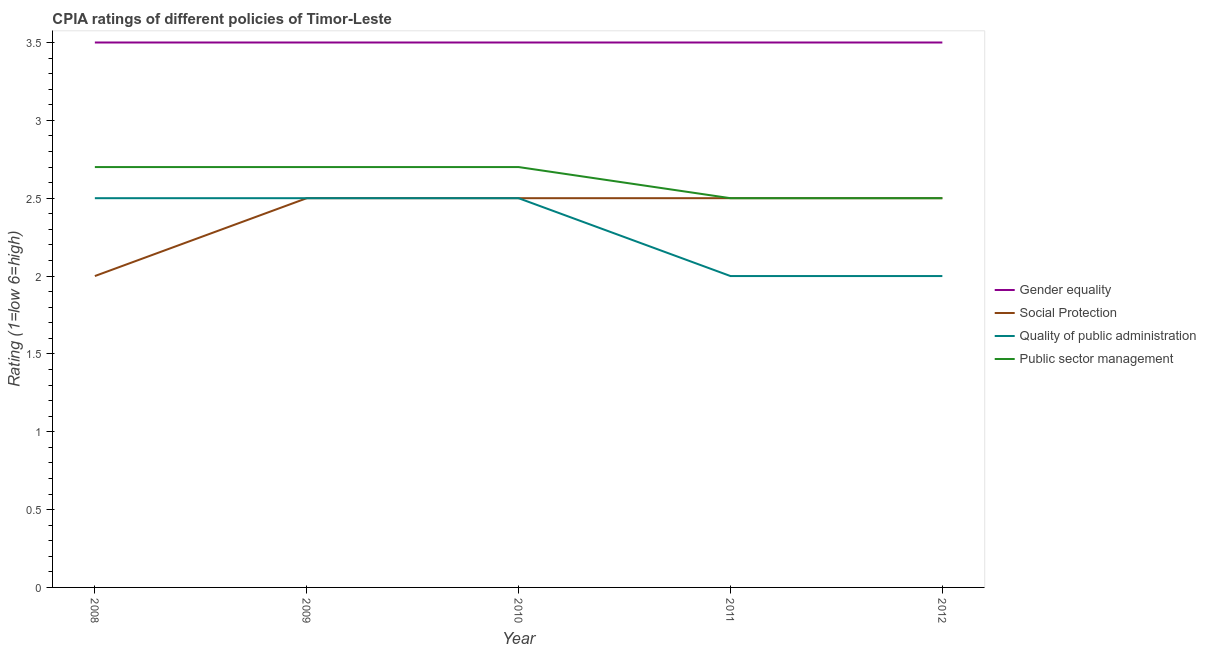How many different coloured lines are there?
Offer a very short reply. 4. Does the line corresponding to cpia rating of social protection intersect with the line corresponding to cpia rating of quality of public administration?
Keep it short and to the point. Yes. Across all years, what is the maximum cpia rating of gender equality?
Give a very brief answer. 3.5. In which year was the cpia rating of social protection maximum?
Provide a succinct answer. 2009. What is the difference between the cpia rating of public sector management in 2008 and the cpia rating of quality of public administration in 2010?
Your response must be concise. 0.2. What is the average cpia rating of quality of public administration per year?
Provide a succinct answer. 2.3. In the year 2012, what is the difference between the cpia rating of quality of public administration and cpia rating of gender equality?
Your response must be concise. -1.5. In how many years, is the cpia rating of quality of public administration greater than 2.8?
Your answer should be compact. 0. What is the ratio of the cpia rating of gender equality in 2009 to that in 2010?
Make the answer very short. 1. Is the cpia rating of social protection in 2008 less than that in 2011?
Make the answer very short. Yes. Is the difference between the cpia rating of social protection in 2009 and 2012 greater than the difference between the cpia rating of quality of public administration in 2009 and 2012?
Give a very brief answer. No. Is the sum of the cpia rating of social protection in 2008 and 2011 greater than the maximum cpia rating of public sector management across all years?
Your answer should be very brief. Yes. Is it the case that in every year, the sum of the cpia rating of quality of public administration and cpia rating of public sector management is greater than the sum of cpia rating of gender equality and cpia rating of social protection?
Ensure brevity in your answer.  No. Is it the case that in every year, the sum of the cpia rating of gender equality and cpia rating of social protection is greater than the cpia rating of quality of public administration?
Provide a short and direct response. Yes. Does the cpia rating of social protection monotonically increase over the years?
Give a very brief answer. No. Is the cpia rating of public sector management strictly less than the cpia rating of gender equality over the years?
Keep it short and to the point. Yes. Are the values on the major ticks of Y-axis written in scientific E-notation?
Provide a short and direct response. No. Does the graph contain any zero values?
Your response must be concise. No. Does the graph contain grids?
Give a very brief answer. No. How many legend labels are there?
Provide a succinct answer. 4. How are the legend labels stacked?
Your response must be concise. Vertical. What is the title of the graph?
Ensure brevity in your answer.  CPIA ratings of different policies of Timor-Leste. What is the Rating (1=low 6=high) of Social Protection in 2008?
Offer a very short reply. 2. What is the Rating (1=low 6=high) in Quality of public administration in 2008?
Ensure brevity in your answer.  2.5. What is the Rating (1=low 6=high) in Public sector management in 2008?
Make the answer very short. 2.7. What is the Rating (1=low 6=high) in Social Protection in 2009?
Offer a very short reply. 2.5. What is the Rating (1=low 6=high) of Public sector management in 2009?
Keep it short and to the point. 2.7. What is the Rating (1=low 6=high) of Gender equality in 2010?
Make the answer very short. 3.5. What is the Rating (1=low 6=high) of Quality of public administration in 2010?
Ensure brevity in your answer.  2.5. What is the Rating (1=low 6=high) in Gender equality in 2011?
Ensure brevity in your answer.  3.5. What is the Rating (1=low 6=high) in Gender equality in 2012?
Make the answer very short. 3.5. What is the Rating (1=low 6=high) in Quality of public administration in 2012?
Your answer should be compact. 2. What is the Rating (1=low 6=high) in Public sector management in 2012?
Make the answer very short. 2.5. Across all years, what is the maximum Rating (1=low 6=high) of Social Protection?
Your answer should be very brief. 2.5. Across all years, what is the maximum Rating (1=low 6=high) of Public sector management?
Provide a succinct answer. 2.7. Across all years, what is the minimum Rating (1=low 6=high) in Social Protection?
Your answer should be compact. 2. What is the total Rating (1=low 6=high) in Gender equality in the graph?
Offer a very short reply. 17.5. What is the total Rating (1=low 6=high) in Quality of public administration in the graph?
Make the answer very short. 11.5. What is the difference between the Rating (1=low 6=high) in Gender equality in 2008 and that in 2009?
Ensure brevity in your answer.  0. What is the difference between the Rating (1=low 6=high) of Social Protection in 2008 and that in 2009?
Provide a succinct answer. -0.5. What is the difference between the Rating (1=low 6=high) in Public sector management in 2008 and that in 2010?
Offer a very short reply. 0. What is the difference between the Rating (1=low 6=high) in Gender equality in 2008 and that in 2011?
Provide a short and direct response. 0. What is the difference between the Rating (1=low 6=high) in Social Protection in 2008 and that in 2011?
Your response must be concise. -0.5. What is the difference between the Rating (1=low 6=high) in Public sector management in 2008 and that in 2011?
Ensure brevity in your answer.  0.2. What is the difference between the Rating (1=low 6=high) of Quality of public administration in 2008 and that in 2012?
Offer a terse response. 0.5. What is the difference between the Rating (1=low 6=high) in Gender equality in 2009 and that in 2010?
Keep it short and to the point. 0. What is the difference between the Rating (1=low 6=high) of Social Protection in 2009 and that in 2011?
Provide a short and direct response. 0. What is the difference between the Rating (1=low 6=high) in Quality of public administration in 2009 and that in 2011?
Provide a succinct answer. 0.5. What is the difference between the Rating (1=low 6=high) in Gender equality in 2009 and that in 2012?
Your answer should be compact. 0. What is the difference between the Rating (1=low 6=high) of Gender equality in 2010 and that in 2011?
Your answer should be compact. 0. What is the difference between the Rating (1=low 6=high) of Social Protection in 2010 and that in 2011?
Keep it short and to the point. 0. What is the difference between the Rating (1=low 6=high) of Gender equality in 2010 and that in 2012?
Make the answer very short. 0. What is the difference between the Rating (1=low 6=high) in Social Protection in 2010 and that in 2012?
Your answer should be compact. 0. What is the difference between the Rating (1=low 6=high) of Public sector management in 2010 and that in 2012?
Make the answer very short. 0.2. What is the difference between the Rating (1=low 6=high) of Social Protection in 2011 and that in 2012?
Make the answer very short. 0. What is the difference between the Rating (1=low 6=high) in Gender equality in 2008 and the Rating (1=low 6=high) in Quality of public administration in 2009?
Your response must be concise. 1. What is the difference between the Rating (1=low 6=high) in Gender equality in 2008 and the Rating (1=low 6=high) in Public sector management in 2009?
Your answer should be very brief. 0.8. What is the difference between the Rating (1=low 6=high) in Social Protection in 2008 and the Rating (1=low 6=high) in Quality of public administration in 2009?
Make the answer very short. -0.5. What is the difference between the Rating (1=low 6=high) of Gender equality in 2008 and the Rating (1=low 6=high) of Social Protection in 2010?
Ensure brevity in your answer.  1. What is the difference between the Rating (1=low 6=high) of Gender equality in 2008 and the Rating (1=low 6=high) of Public sector management in 2010?
Keep it short and to the point. 0.8. What is the difference between the Rating (1=low 6=high) in Social Protection in 2008 and the Rating (1=low 6=high) in Public sector management in 2010?
Provide a succinct answer. -0.7. What is the difference between the Rating (1=low 6=high) of Gender equality in 2008 and the Rating (1=low 6=high) of Social Protection in 2011?
Ensure brevity in your answer.  1. What is the difference between the Rating (1=low 6=high) of Gender equality in 2008 and the Rating (1=low 6=high) of Quality of public administration in 2011?
Your answer should be compact. 1.5. What is the difference between the Rating (1=low 6=high) of Gender equality in 2008 and the Rating (1=low 6=high) of Public sector management in 2011?
Your response must be concise. 1. What is the difference between the Rating (1=low 6=high) in Quality of public administration in 2008 and the Rating (1=low 6=high) in Public sector management in 2011?
Make the answer very short. 0. What is the difference between the Rating (1=low 6=high) of Gender equality in 2008 and the Rating (1=low 6=high) of Social Protection in 2012?
Give a very brief answer. 1. What is the difference between the Rating (1=low 6=high) of Gender equality in 2008 and the Rating (1=low 6=high) of Quality of public administration in 2012?
Provide a short and direct response. 1.5. What is the difference between the Rating (1=low 6=high) of Gender equality in 2008 and the Rating (1=low 6=high) of Public sector management in 2012?
Your response must be concise. 1. What is the difference between the Rating (1=low 6=high) in Social Protection in 2008 and the Rating (1=low 6=high) in Quality of public administration in 2012?
Keep it short and to the point. 0. What is the difference between the Rating (1=low 6=high) of Quality of public administration in 2008 and the Rating (1=low 6=high) of Public sector management in 2012?
Give a very brief answer. 0. What is the difference between the Rating (1=low 6=high) in Gender equality in 2009 and the Rating (1=low 6=high) in Quality of public administration in 2010?
Your answer should be compact. 1. What is the difference between the Rating (1=low 6=high) of Gender equality in 2009 and the Rating (1=low 6=high) of Public sector management in 2010?
Give a very brief answer. 0.8. What is the difference between the Rating (1=low 6=high) of Social Protection in 2009 and the Rating (1=low 6=high) of Quality of public administration in 2010?
Provide a short and direct response. 0. What is the difference between the Rating (1=low 6=high) in Social Protection in 2009 and the Rating (1=low 6=high) in Public sector management in 2010?
Offer a terse response. -0.2. What is the difference between the Rating (1=low 6=high) in Quality of public administration in 2009 and the Rating (1=low 6=high) in Public sector management in 2010?
Your answer should be very brief. -0.2. What is the difference between the Rating (1=low 6=high) in Social Protection in 2009 and the Rating (1=low 6=high) in Quality of public administration in 2011?
Provide a succinct answer. 0.5. What is the difference between the Rating (1=low 6=high) of Quality of public administration in 2009 and the Rating (1=low 6=high) of Public sector management in 2011?
Your answer should be compact. 0. What is the difference between the Rating (1=low 6=high) of Gender equality in 2009 and the Rating (1=low 6=high) of Social Protection in 2012?
Offer a terse response. 1. What is the difference between the Rating (1=low 6=high) in Gender equality in 2009 and the Rating (1=low 6=high) in Quality of public administration in 2012?
Your answer should be compact. 1.5. What is the difference between the Rating (1=low 6=high) in Gender equality in 2009 and the Rating (1=low 6=high) in Public sector management in 2012?
Provide a short and direct response. 1. What is the difference between the Rating (1=low 6=high) of Gender equality in 2010 and the Rating (1=low 6=high) of Social Protection in 2011?
Offer a very short reply. 1. What is the difference between the Rating (1=low 6=high) in Gender equality in 2010 and the Rating (1=low 6=high) in Quality of public administration in 2011?
Your response must be concise. 1.5. What is the difference between the Rating (1=low 6=high) in Gender equality in 2010 and the Rating (1=low 6=high) in Social Protection in 2012?
Ensure brevity in your answer.  1. What is the difference between the Rating (1=low 6=high) of Gender equality in 2010 and the Rating (1=low 6=high) of Quality of public administration in 2012?
Provide a succinct answer. 1.5. What is the difference between the Rating (1=low 6=high) in Social Protection in 2010 and the Rating (1=low 6=high) in Quality of public administration in 2012?
Offer a very short reply. 0.5. What is the difference between the Rating (1=low 6=high) in Gender equality in 2011 and the Rating (1=low 6=high) in Social Protection in 2012?
Keep it short and to the point. 1. What is the difference between the Rating (1=low 6=high) in Gender equality in 2011 and the Rating (1=low 6=high) in Public sector management in 2012?
Give a very brief answer. 1. What is the difference between the Rating (1=low 6=high) of Social Protection in 2011 and the Rating (1=low 6=high) of Public sector management in 2012?
Keep it short and to the point. 0. What is the average Rating (1=low 6=high) of Social Protection per year?
Keep it short and to the point. 2.4. What is the average Rating (1=low 6=high) in Quality of public administration per year?
Offer a terse response. 2.3. What is the average Rating (1=low 6=high) in Public sector management per year?
Provide a short and direct response. 2.62. In the year 2008, what is the difference between the Rating (1=low 6=high) in Gender equality and Rating (1=low 6=high) in Social Protection?
Provide a short and direct response. 1.5. In the year 2008, what is the difference between the Rating (1=low 6=high) of Gender equality and Rating (1=low 6=high) of Quality of public administration?
Make the answer very short. 1. In the year 2008, what is the difference between the Rating (1=low 6=high) of Gender equality and Rating (1=low 6=high) of Public sector management?
Ensure brevity in your answer.  0.8. In the year 2009, what is the difference between the Rating (1=low 6=high) in Gender equality and Rating (1=low 6=high) in Social Protection?
Keep it short and to the point. 1. In the year 2009, what is the difference between the Rating (1=low 6=high) in Gender equality and Rating (1=low 6=high) in Public sector management?
Offer a terse response. 0.8. In the year 2009, what is the difference between the Rating (1=low 6=high) in Social Protection and Rating (1=low 6=high) in Quality of public administration?
Ensure brevity in your answer.  0. In the year 2009, what is the difference between the Rating (1=low 6=high) in Social Protection and Rating (1=low 6=high) in Public sector management?
Offer a very short reply. -0.2. In the year 2010, what is the difference between the Rating (1=low 6=high) in Gender equality and Rating (1=low 6=high) in Social Protection?
Offer a terse response. 1. In the year 2010, what is the difference between the Rating (1=low 6=high) in Gender equality and Rating (1=low 6=high) in Public sector management?
Your answer should be compact. 0.8. In the year 2010, what is the difference between the Rating (1=low 6=high) in Social Protection and Rating (1=low 6=high) in Public sector management?
Offer a terse response. -0.2. In the year 2010, what is the difference between the Rating (1=low 6=high) in Quality of public administration and Rating (1=low 6=high) in Public sector management?
Offer a very short reply. -0.2. In the year 2011, what is the difference between the Rating (1=low 6=high) of Gender equality and Rating (1=low 6=high) of Quality of public administration?
Give a very brief answer. 1.5. In the year 2011, what is the difference between the Rating (1=low 6=high) in Social Protection and Rating (1=low 6=high) in Public sector management?
Offer a terse response. 0. In the year 2011, what is the difference between the Rating (1=low 6=high) in Quality of public administration and Rating (1=low 6=high) in Public sector management?
Your answer should be very brief. -0.5. In the year 2012, what is the difference between the Rating (1=low 6=high) of Gender equality and Rating (1=low 6=high) of Social Protection?
Your answer should be very brief. 1. In the year 2012, what is the difference between the Rating (1=low 6=high) in Gender equality and Rating (1=low 6=high) in Public sector management?
Provide a short and direct response. 1. In the year 2012, what is the difference between the Rating (1=low 6=high) in Social Protection and Rating (1=low 6=high) in Quality of public administration?
Keep it short and to the point. 0.5. What is the ratio of the Rating (1=low 6=high) of Gender equality in 2008 to that in 2009?
Offer a very short reply. 1. What is the ratio of the Rating (1=low 6=high) in Social Protection in 2008 to that in 2010?
Make the answer very short. 0.8. What is the ratio of the Rating (1=low 6=high) in Quality of public administration in 2008 to that in 2010?
Your answer should be very brief. 1. What is the ratio of the Rating (1=low 6=high) of Public sector management in 2008 to that in 2010?
Your answer should be compact. 1. What is the ratio of the Rating (1=low 6=high) in Social Protection in 2008 to that in 2011?
Your answer should be very brief. 0.8. What is the ratio of the Rating (1=low 6=high) in Quality of public administration in 2008 to that in 2011?
Provide a short and direct response. 1.25. What is the ratio of the Rating (1=low 6=high) in Public sector management in 2008 to that in 2011?
Offer a very short reply. 1.08. What is the ratio of the Rating (1=low 6=high) in Quality of public administration in 2008 to that in 2012?
Make the answer very short. 1.25. What is the ratio of the Rating (1=low 6=high) of Public sector management in 2008 to that in 2012?
Your answer should be very brief. 1.08. What is the ratio of the Rating (1=low 6=high) of Social Protection in 2009 to that in 2010?
Give a very brief answer. 1. What is the ratio of the Rating (1=low 6=high) in Quality of public administration in 2009 to that in 2010?
Your answer should be compact. 1. What is the ratio of the Rating (1=low 6=high) of Public sector management in 2009 to that in 2010?
Your answer should be very brief. 1. What is the ratio of the Rating (1=low 6=high) of Gender equality in 2009 to that in 2011?
Provide a short and direct response. 1. What is the ratio of the Rating (1=low 6=high) of Social Protection in 2009 to that in 2011?
Ensure brevity in your answer.  1. What is the ratio of the Rating (1=low 6=high) in Quality of public administration in 2009 to that in 2011?
Make the answer very short. 1.25. What is the ratio of the Rating (1=low 6=high) of Public sector management in 2009 to that in 2011?
Offer a terse response. 1.08. What is the ratio of the Rating (1=low 6=high) in Social Protection in 2009 to that in 2012?
Your answer should be compact. 1. What is the ratio of the Rating (1=low 6=high) of Quality of public administration in 2009 to that in 2012?
Your answer should be very brief. 1.25. What is the ratio of the Rating (1=low 6=high) of Public sector management in 2009 to that in 2012?
Make the answer very short. 1.08. What is the ratio of the Rating (1=low 6=high) of Quality of public administration in 2010 to that in 2011?
Provide a short and direct response. 1.25. What is the ratio of the Rating (1=low 6=high) of Public sector management in 2010 to that in 2011?
Provide a short and direct response. 1.08. What is the ratio of the Rating (1=low 6=high) in Gender equality in 2010 to that in 2012?
Make the answer very short. 1. What is the ratio of the Rating (1=low 6=high) of Social Protection in 2010 to that in 2012?
Give a very brief answer. 1. What is the ratio of the Rating (1=low 6=high) of Public sector management in 2010 to that in 2012?
Give a very brief answer. 1.08. What is the ratio of the Rating (1=low 6=high) of Gender equality in 2011 to that in 2012?
Provide a short and direct response. 1. What is the ratio of the Rating (1=low 6=high) of Quality of public administration in 2011 to that in 2012?
Provide a short and direct response. 1. What is the ratio of the Rating (1=low 6=high) in Public sector management in 2011 to that in 2012?
Your response must be concise. 1. What is the difference between the highest and the second highest Rating (1=low 6=high) of Gender equality?
Provide a short and direct response. 0. What is the difference between the highest and the second highest Rating (1=low 6=high) of Social Protection?
Make the answer very short. 0. What is the difference between the highest and the second highest Rating (1=low 6=high) in Quality of public administration?
Offer a terse response. 0. What is the difference between the highest and the second highest Rating (1=low 6=high) of Public sector management?
Make the answer very short. 0. What is the difference between the highest and the lowest Rating (1=low 6=high) of Gender equality?
Provide a short and direct response. 0. What is the difference between the highest and the lowest Rating (1=low 6=high) in Social Protection?
Provide a succinct answer. 0.5. What is the difference between the highest and the lowest Rating (1=low 6=high) of Quality of public administration?
Make the answer very short. 0.5. 